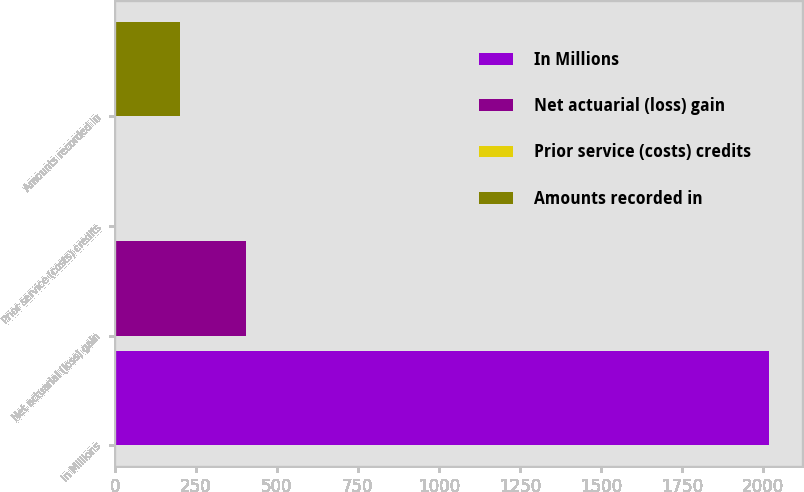<chart> <loc_0><loc_0><loc_500><loc_500><bar_chart><fcel>In Millions<fcel>Net actuarial (loss) gain<fcel>Prior service (costs) credits<fcel>Amounts recorded in<nl><fcel>2018<fcel>403.84<fcel>0.3<fcel>202.07<nl></chart> 